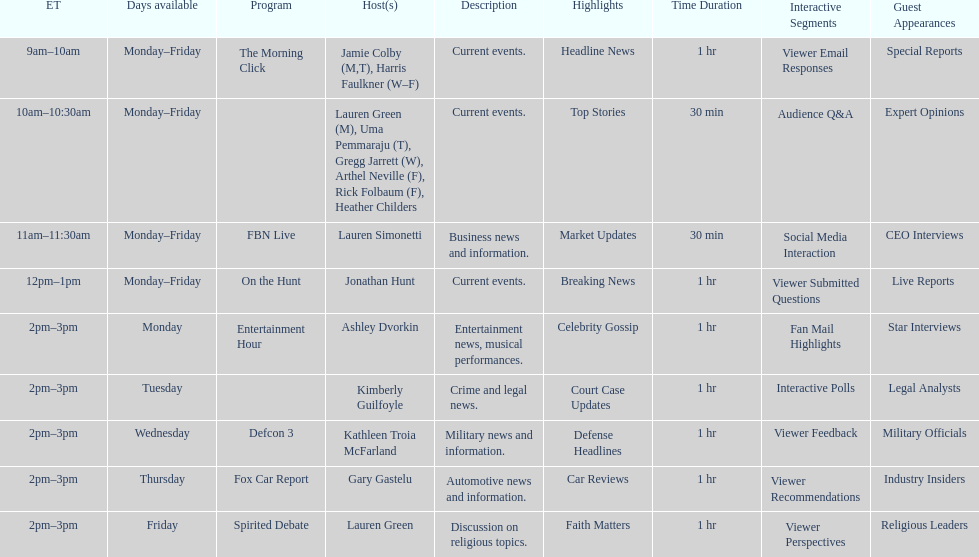Would you be able to parse every entry in this table? {'header': ['ET', 'Days available', 'Program', 'Host(s)', 'Description', 'Highlights', 'Time Duration', 'Interactive Segments', 'Guest Appearances'], 'rows': [['9am–10am', 'Monday–Friday', 'The Morning Click', 'Jamie Colby (M,T), Harris Faulkner (W–F)', 'Current events.', 'Headline News', '1 hr', 'Viewer Email Responses', 'Special Reports'], ['10am–10:30am', 'Monday–Friday', '', 'Lauren Green (M), Uma Pemmaraju (T), Gregg Jarrett (W), Arthel Neville (F), Rick Folbaum (F), Heather Childers', 'Current events.', 'Top Stories', '30 min', 'Audience Q&A', 'Expert Opinions'], ['11am–11:30am', 'Monday–Friday', 'FBN Live', 'Lauren Simonetti', 'Business news and information.', 'Market Updates', '30 min', 'Social Media Interaction', 'CEO Interviews'], ['12pm–1pm', 'Monday–Friday', 'On the Hunt', 'Jonathan Hunt', 'Current events.', 'Breaking News', '1 hr', 'Viewer Submitted Questions', 'Live Reports '], ['2pm–3pm', 'Monday', 'Entertainment Hour', 'Ashley Dvorkin', 'Entertainment news, musical performances.', 'Celebrity Gossip', '1 hr', 'Fan Mail Highlights', 'Star Interviews'], ['2pm–3pm', 'Tuesday', '', 'Kimberly Guilfoyle', 'Crime and legal news.', 'Court Case Updates', '1 hr', 'Interactive Polls', 'Legal Analysts'], ['2pm–3pm', 'Wednesday', 'Defcon 3', 'Kathleen Troia McFarland', 'Military news and information.', 'Defense Headlines', '1 hr', 'Viewer Feedback', 'Military Officials'], ['2pm–3pm', 'Thursday', 'Fox Car Report', 'Gary Gastelu', 'Automotive news and information.', 'Car Reviews', '1 hr', 'Viewer Recommendations', 'Industry Insiders'], ['2pm–3pm', 'Friday', 'Spirited Debate', 'Lauren Green', 'Discussion on religious topics.', 'Faith Matters', '1 hr', 'Viewer Perspectives', 'Religious Leaders']]} How many shows have just one host each day? 7. 